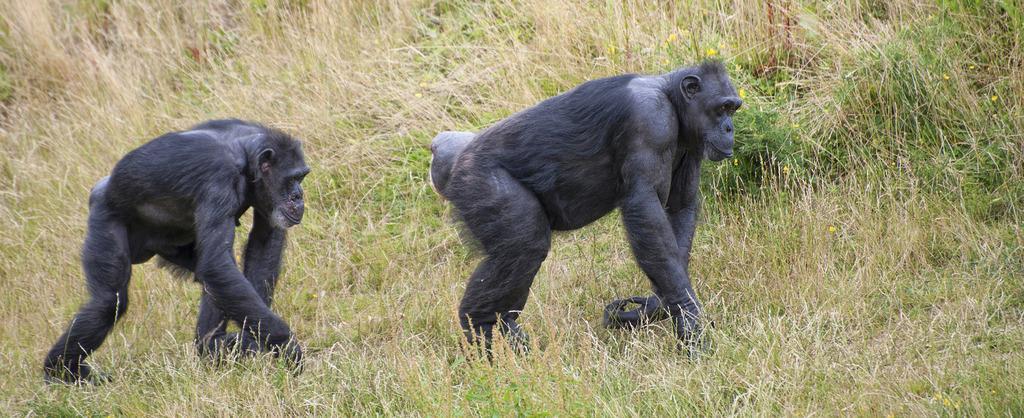In one or two sentences, can you explain what this image depicts? In this picture we can see chimpanzees, grass and flowers. 